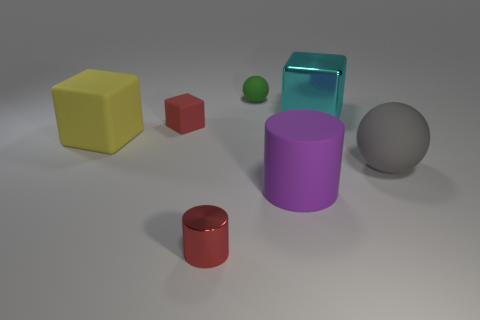There is a cyan metallic object that is the same shape as the red rubber thing; what is its size?
Your answer should be compact. Large. What material is the other tiny thing that is the same shape as the yellow matte object?
Give a very brief answer. Rubber. There is a metallic object that is the same color as the tiny cube; what is its size?
Make the answer very short. Small. There is a matte thing that is on the right side of the small red block and behind the yellow thing; what size is it?
Make the answer very short. Small. There is a shiny thing that is on the left side of the cyan cube; what size is it?
Your response must be concise. Small. The other object that is the same color as the small metallic object is what shape?
Your answer should be very brief. Cube. The gray object that is in front of the red object that is behind the red object to the right of the red block is what shape?
Make the answer very short. Sphere. How many other objects are there of the same shape as the big shiny object?
Provide a short and direct response. 2. What number of metallic things are either blue spheres or green objects?
Your response must be concise. 0. What material is the sphere that is on the right side of the metal thing to the right of the big purple matte object?
Give a very brief answer. Rubber. 